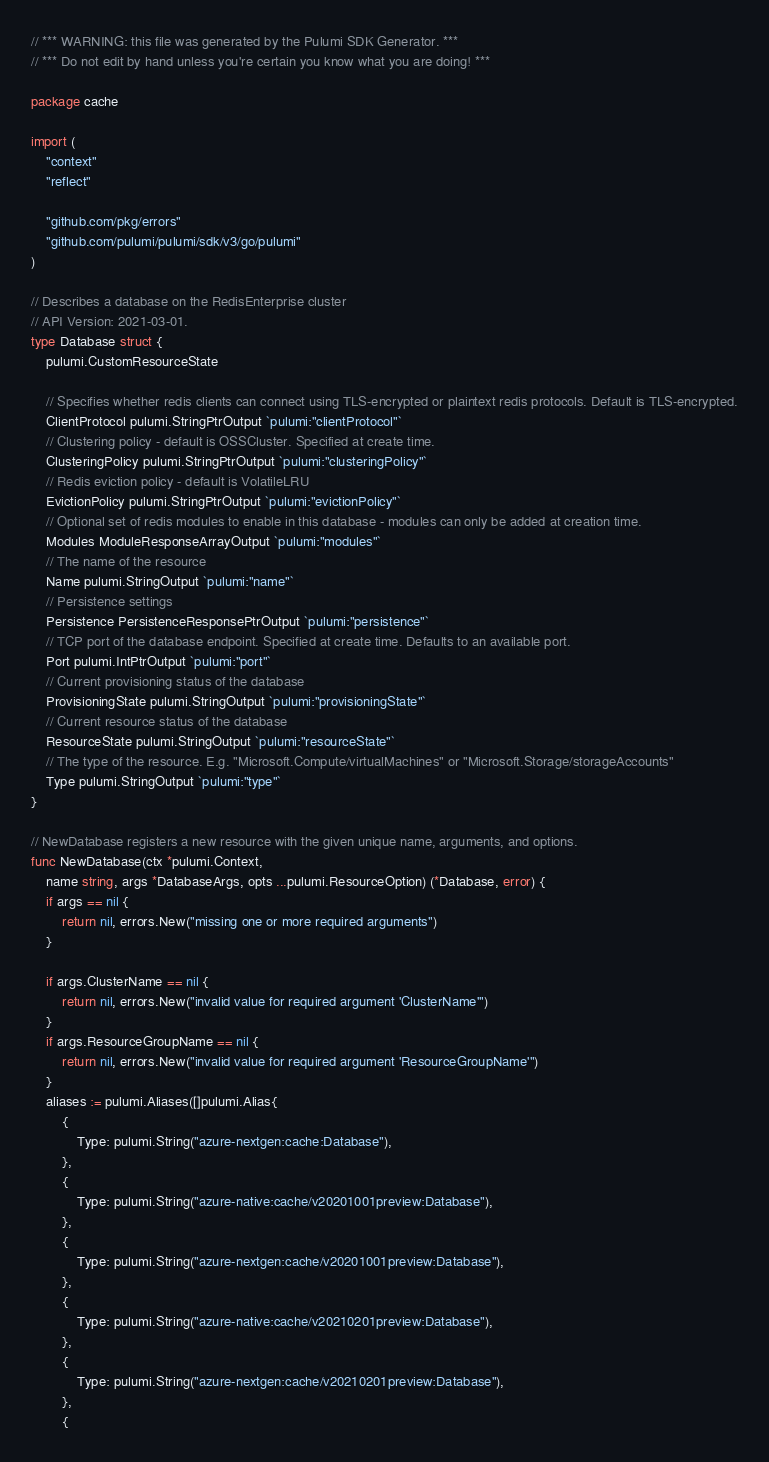<code> <loc_0><loc_0><loc_500><loc_500><_Go_>// *** WARNING: this file was generated by the Pulumi SDK Generator. ***
// *** Do not edit by hand unless you're certain you know what you are doing! ***

package cache

import (
	"context"
	"reflect"

	"github.com/pkg/errors"
	"github.com/pulumi/pulumi/sdk/v3/go/pulumi"
)

// Describes a database on the RedisEnterprise cluster
// API Version: 2021-03-01.
type Database struct {
	pulumi.CustomResourceState

	// Specifies whether redis clients can connect using TLS-encrypted or plaintext redis protocols. Default is TLS-encrypted.
	ClientProtocol pulumi.StringPtrOutput `pulumi:"clientProtocol"`
	// Clustering policy - default is OSSCluster. Specified at create time.
	ClusteringPolicy pulumi.StringPtrOutput `pulumi:"clusteringPolicy"`
	// Redis eviction policy - default is VolatileLRU
	EvictionPolicy pulumi.StringPtrOutput `pulumi:"evictionPolicy"`
	// Optional set of redis modules to enable in this database - modules can only be added at creation time.
	Modules ModuleResponseArrayOutput `pulumi:"modules"`
	// The name of the resource
	Name pulumi.StringOutput `pulumi:"name"`
	// Persistence settings
	Persistence PersistenceResponsePtrOutput `pulumi:"persistence"`
	// TCP port of the database endpoint. Specified at create time. Defaults to an available port.
	Port pulumi.IntPtrOutput `pulumi:"port"`
	// Current provisioning status of the database
	ProvisioningState pulumi.StringOutput `pulumi:"provisioningState"`
	// Current resource status of the database
	ResourceState pulumi.StringOutput `pulumi:"resourceState"`
	// The type of the resource. E.g. "Microsoft.Compute/virtualMachines" or "Microsoft.Storage/storageAccounts"
	Type pulumi.StringOutput `pulumi:"type"`
}

// NewDatabase registers a new resource with the given unique name, arguments, and options.
func NewDatabase(ctx *pulumi.Context,
	name string, args *DatabaseArgs, opts ...pulumi.ResourceOption) (*Database, error) {
	if args == nil {
		return nil, errors.New("missing one or more required arguments")
	}

	if args.ClusterName == nil {
		return nil, errors.New("invalid value for required argument 'ClusterName'")
	}
	if args.ResourceGroupName == nil {
		return nil, errors.New("invalid value for required argument 'ResourceGroupName'")
	}
	aliases := pulumi.Aliases([]pulumi.Alias{
		{
			Type: pulumi.String("azure-nextgen:cache:Database"),
		},
		{
			Type: pulumi.String("azure-native:cache/v20201001preview:Database"),
		},
		{
			Type: pulumi.String("azure-nextgen:cache/v20201001preview:Database"),
		},
		{
			Type: pulumi.String("azure-native:cache/v20210201preview:Database"),
		},
		{
			Type: pulumi.String("azure-nextgen:cache/v20210201preview:Database"),
		},
		{</code> 